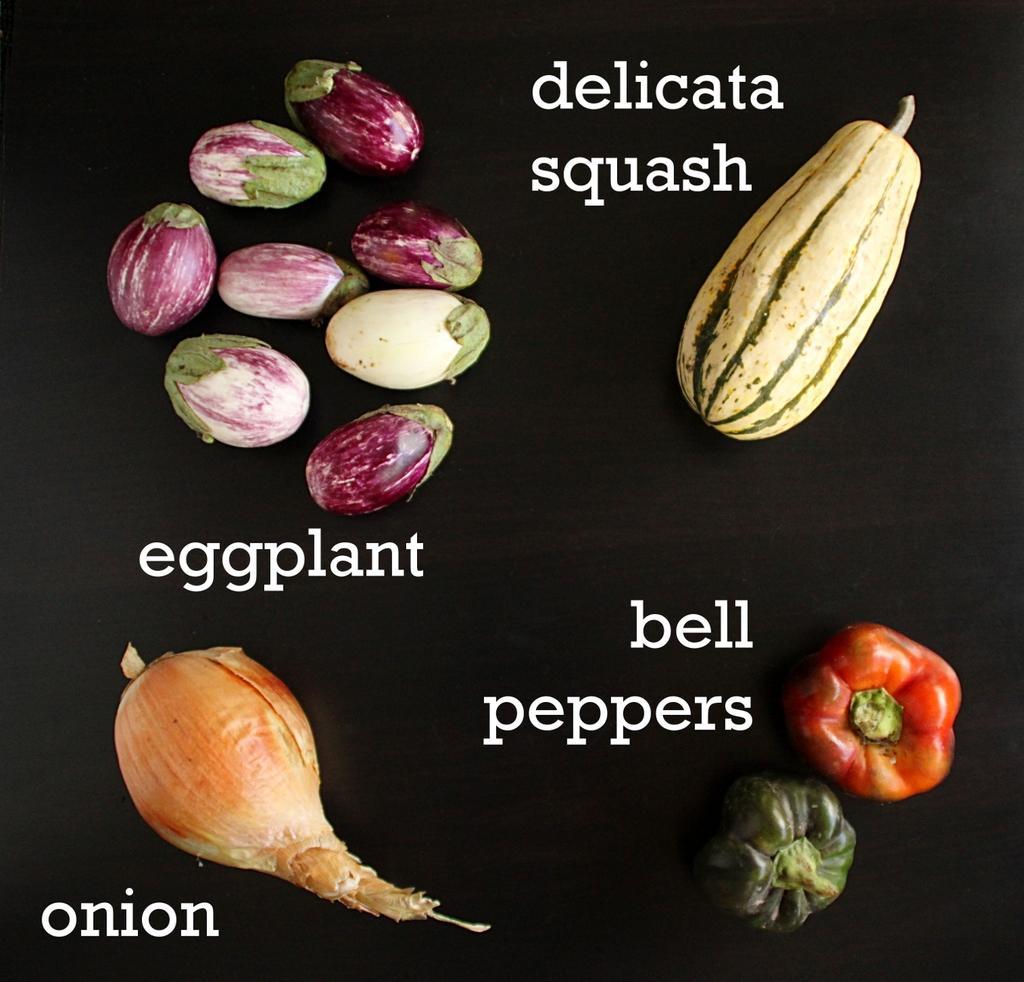How would you summarize this image in a sentence or two? In this picture, we can see a poster of some vegetables and text on it, and we can see the dark background. 